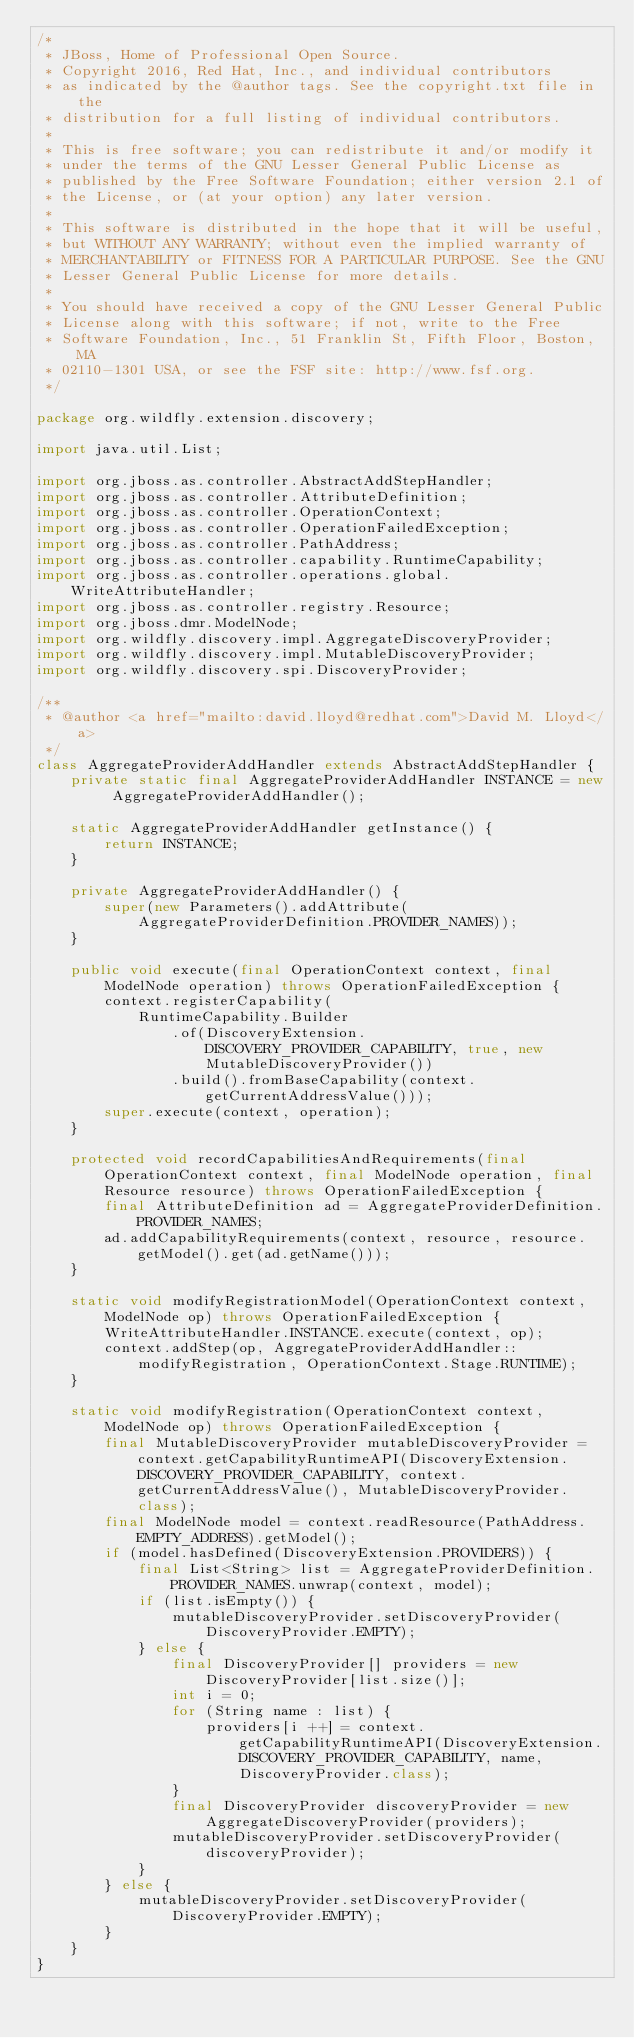Convert code to text. <code><loc_0><loc_0><loc_500><loc_500><_Java_>/*
 * JBoss, Home of Professional Open Source.
 * Copyright 2016, Red Hat, Inc., and individual contributors
 * as indicated by the @author tags. See the copyright.txt file in the
 * distribution for a full listing of individual contributors.
 *
 * This is free software; you can redistribute it and/or modify it
 * under the terms of the GNU Lesser General Public License as
 * published by the Free Software Foundation; either version 2.1 of
 * the License, or (at your option) any later version.
 *
 * This software is distributed in the hope that it will be useful,
 * but WITHOUT ANY WARRANTY; without even the implied warranty of
 * MERCHANTABILITY or FITNESS FOR A PARTICULAR PURPOSE. See the GNU
 * Lesser General Public License for more details.
 *
 * You should have received a copy of the GNU Lesser General Public
 * License along with this software; if not, write to the Free
 * Software Foundation, Inc., 51 Franklin St, Fifth Floor, Boston, MA
 * 02110-1301 USA, or see the FSF site: http://www.fsf.org.
 */

package org.wildfly.extension.discovery;

import java.util.List;

import org.jboss.as.controller.AbstractAddStepHandler;
import org.jboss.as.controller.AttributeDefinition;
import org.jboss.as.controller.OperationContext;
import org.jboss.as.controller.OperationFailedException;
import org.jboss.as.controller.PathAddress;
import org.jboss.as.controller.capability.RuntimeCapability;
import org.jboss.as.controller.operations.global.WriteAttributeHandler;
import org.jboss.as.controller.registry.Resource;
import org.jboss.dmr.ModelNode;
import org.wildfly.discovery.impl.AggregateDiscoveryProvider;
import org.wildfly.discovery.impl.MutableDiscoveryProvider;
import org.wildfly.discovery.spi.DiscoveryProvider;

/**
 * @author <a href="mailto:david.lloyd@redhat.com">David M. Lloyd</a>
 */
class AggregateProviderAddHandler extends AbstractAddStepHandler {
    private static final AggregateProviderAddHandler INSTANCE = new AggregateProviderAddHandler();

    static AggregateProviderAddHandler getInstance() {
        return INSTANCE;
    }

    private AggregateProviderAddHandler() {
        super(new Parameters().addAttribute(AggregateProviderDefinition.PROVIDER_NAMES));
    }

    public void execute(final OperationContext context, final ModelNode operation) throws OperationFailedException {
        context.registerCapability(
            RuntimeCapability.Builder
                .of(DiscoveryExtension.DISCOVERY_PROVIDER_CAPABILITY, true, new MutableDiscoveryProvider())
                .build().fromBaseCapability(context.getCurrentAddressValue()));
        super.execute(context, operation);
    }

    protected void recordCapabilitiesAndRequirements(final OperationContext context, final ModelNode operation, final Resource resource) throws OperationFailedException {
        final AttributeDefinition ad = AggregateProviderDefinition.PROVIDER_NAMES;
        ad.addCapabilityRequirements(context, resource, resource.getModel().get(ad.getName()));
    }

    static void modifyRegistrationModel(OperationContext context, ModelNode op) throws OperationFailedException {
        WriteAttributeHandler.INSTANCE.execute(context, op);
        context.addStep(op, AggregateProviderAddHandler::modifyRegistration, OperationContext.Stage.RUNTIME);
    }

    static void modifyRegistration(OperationContext context, ModelNode op) throws OperationFailedException {
        final MutableDiscoveryProvider mutableDiscoveryProvider = context.getCapabilityRuntimeAPI(DiscoveryExtension.DISCOVERY_PROVIDER_CAPABILITY, context.getCurrentAddressValue(), MutableDiscoveryProvider.class);
        final ModelNode model = context.readResource(PathAddress.EMPTY_ADDRESS).getModel();
        if (model.hasDefined(DiscoveryExtension.PROVIDERS)) {
            final List<String> list = AggregateProviderDefinition.PROVIDER_NAMES.unwrap(context, model);
            if (list.isEmpty()) {
                mutableDiscoveryProvider.setDiscoveryProvider(DiscoveryProvider.EMPTY);
            } else {
                final DiscoveryProvider[] providers = new DiscoveryProvider[list.size()];
                int i = 0;
                for (String name : list) {
                    providers[i ++] = context.getCapabilityRuntimeAPI(DiscoveryExtension.DISCOVERY_PROVIDER_CAPABILITY, name, DiscoveryProvider.class);
                }
                final DiscoveryProvider discoveryProvider = new AggregateDiscoveryProvider(providers);
                mutableDiscoveryProvider.setDiscoveryProvider(discoveryProvider);
            }
        } else {
            mutableDiscoveryProvider.setDiscoveryProvider(DiscoveryProvider.EMPTY);
        }
    }
}
</code> 